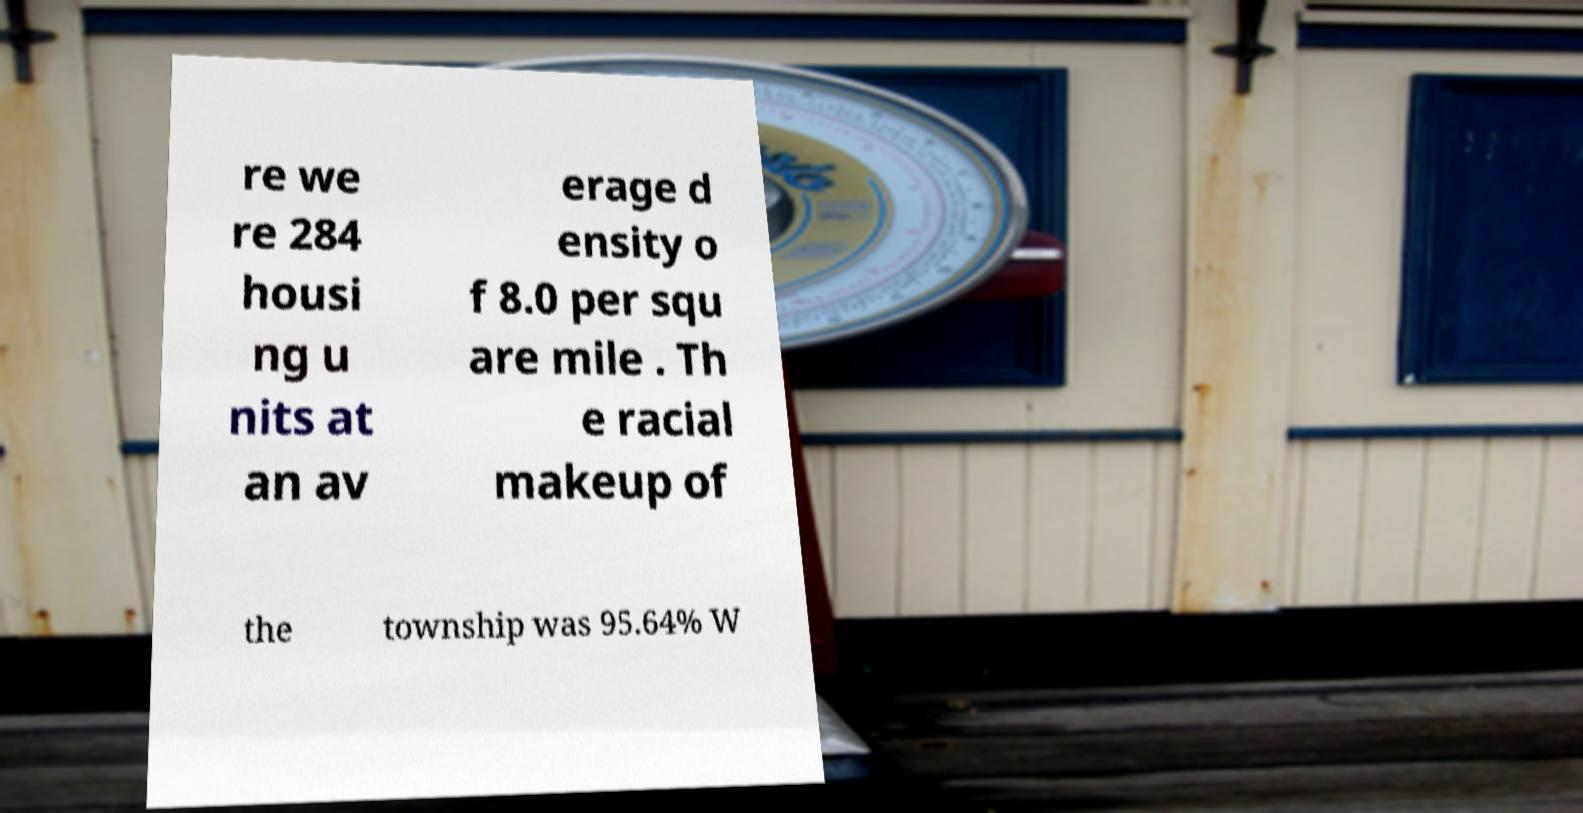Please read and relay the text visible in this image. What does it say? re we re 284 housi ng u nits at an av erage d ensity o f 8.0 per squ are mile . Th e racial makeup of the township was 95.64% W 